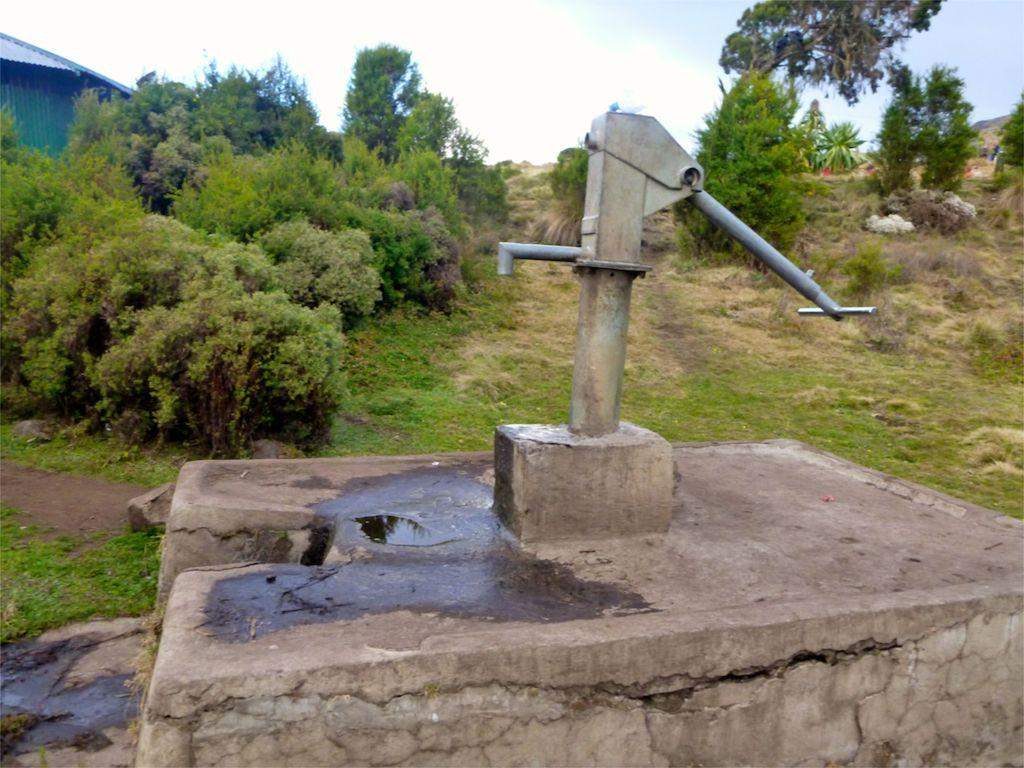What is the main object in the image? There is a hand pump in the image. What type of natural elements can be seen in the image? There are trees and plants in the image. Where is the shed located in the image? The shed is in the left corner of the image. What is visible in the background of the image? The sky is visible in the background of the image. What type of butter is being used to grease the hand pump in the image? There is no butter present in the image, and the hand pump does not require greasing. 